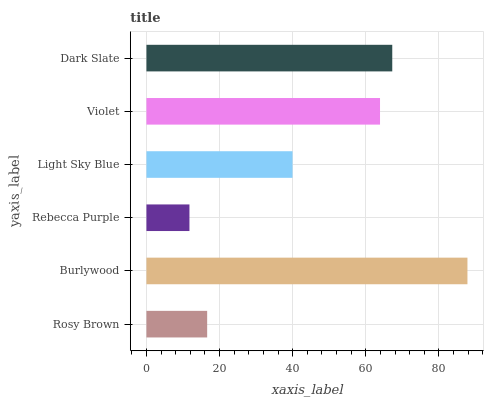Is Rebecca Purple the minimum?
Answer yes or no. Yes. Is Burlywood the maximum?
Answer yes or no. Yes. Is Burlywood the minimum?
Answer yes or no. No. Is Rebecca Purple the maximum?
Answer yes or no. No. Is Burlywood greater than Rebecca Purple?
Answer yes or no. Yes. Is Rebecca Purple less than Burlywood?
Answer yes or no. Yes. Is Rebecca Purple greater than Burlywood?
Answer yes or no. No. Is Burlywood less than Rebecca Purple?
Answer yes or no. No. Is Violet the high median?
Answer yes or no. Yes. Is Light Sky Blue the low median?
Answer yes or no. Yes. Is Burlywood the high median?
Answer yes or no. No. Is Dark Slate the low median?
Answer yes or no. No. 